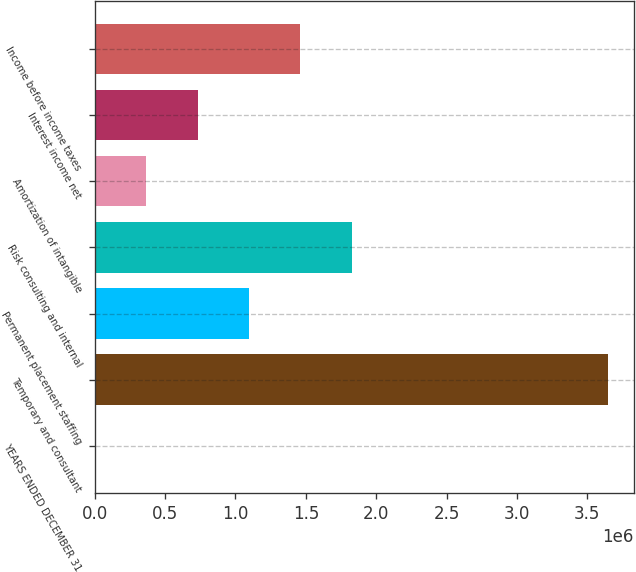<chart> <loc_0><loc_0><loc_500><loc_500><bar_chart><fcel>YEARS ENDED DECEMBER 31<fcel>Temporary and consultant<fcel>Permanent placement staffing<fcel>Risk consulting and internal<fcel>Amortization of intangible<fcel>Interest income net<fcel>Income before income taxes<nl><fcel>2007<fcel>3.64927e+06<fcel>1.09619e+06<fcel>1.82564e+06<fcel>366734<fcel>731460<fcel>1.46091e+06<nl></chart> 